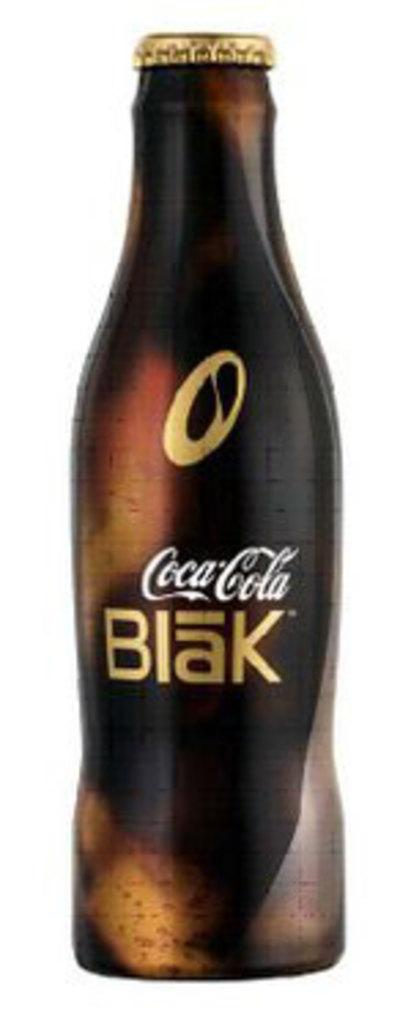<image>
Create a compact narrative representing the image presented. A bottle of Coca-Cola blak stand alone again a white background. 